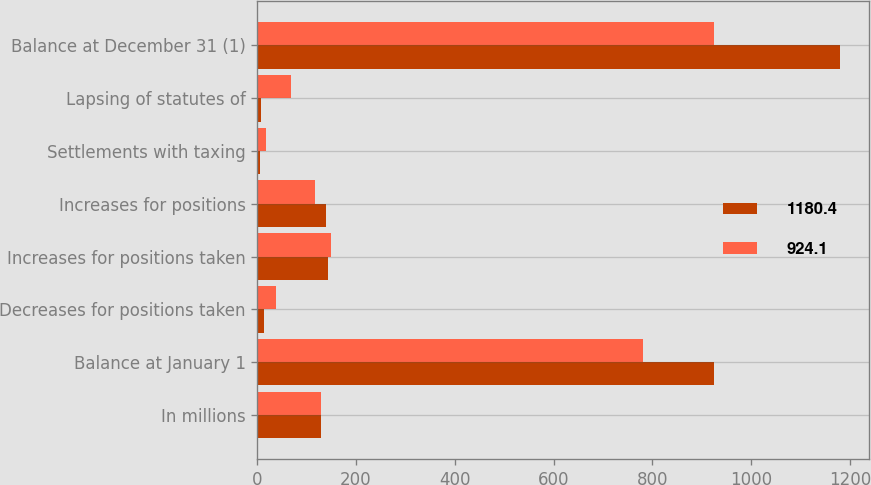<chart> <loc_0><loc_0><loc_500><loc_500><stacked_bar_chart><ecel><fcel>In millions<fcel>Balance at January 1<fcel>Decreases for positions taken<fcel>Increases for positions taken<fcel>Increases for positions<fcel>Settlements with taxing<fcel>Lapsing of statutes of<fcel>Balance at December 31 (1)<nl><fcel>1180.4<fcel>128.4<fcel>924.1<fcel>13.7<fcel>143.9<fcel>140.2<fcel>6.5<fcel>7.6<fcel>1180.4<nl><fcel>924.1<fcel>128.4<fcel>781.2<fcel>37.1<fcel>150.1<fcel>116.6<fcel>17.7<fcel>69<fcel>924.1<nl></chart> 